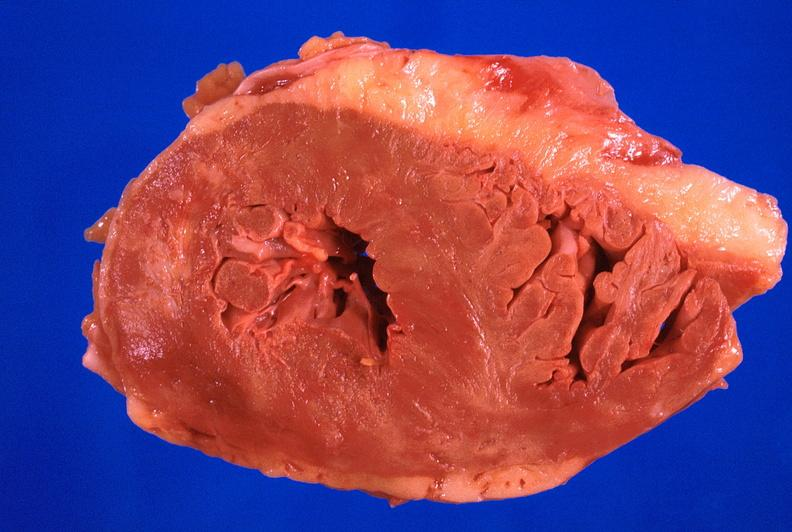where is this?
Answer the question using a single word or phrase. Heart 